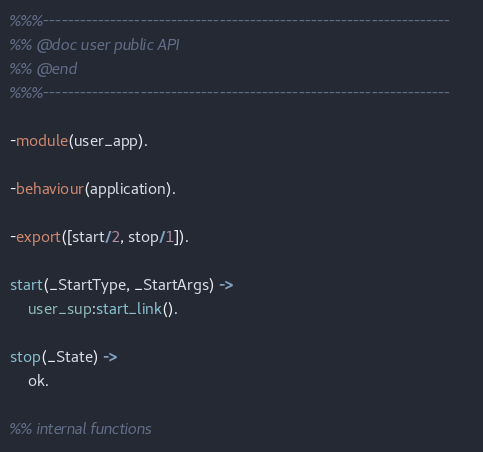<code> <loc_0><loc_0><loc_500><loc_500><_Erlang_>%%%-------------------------------------------------------------------
%% @doc user public API
%% @end
%%%-------------------------------------------------------------------

-module(user_app).

-behaviour(application).

-export([start/2, stop/1]).

start(_StartType, _StartArgs) ->
    user_sup:start_link().

stop(_State) ->
    ok.

%% internal functions
</code> 